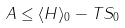Convert formula to latex. <formula><loc_0><loc_0><loc_500><loc_500>A \leq \langle H \rangle _ { 0 } - T S _ { 0 }</formula> 